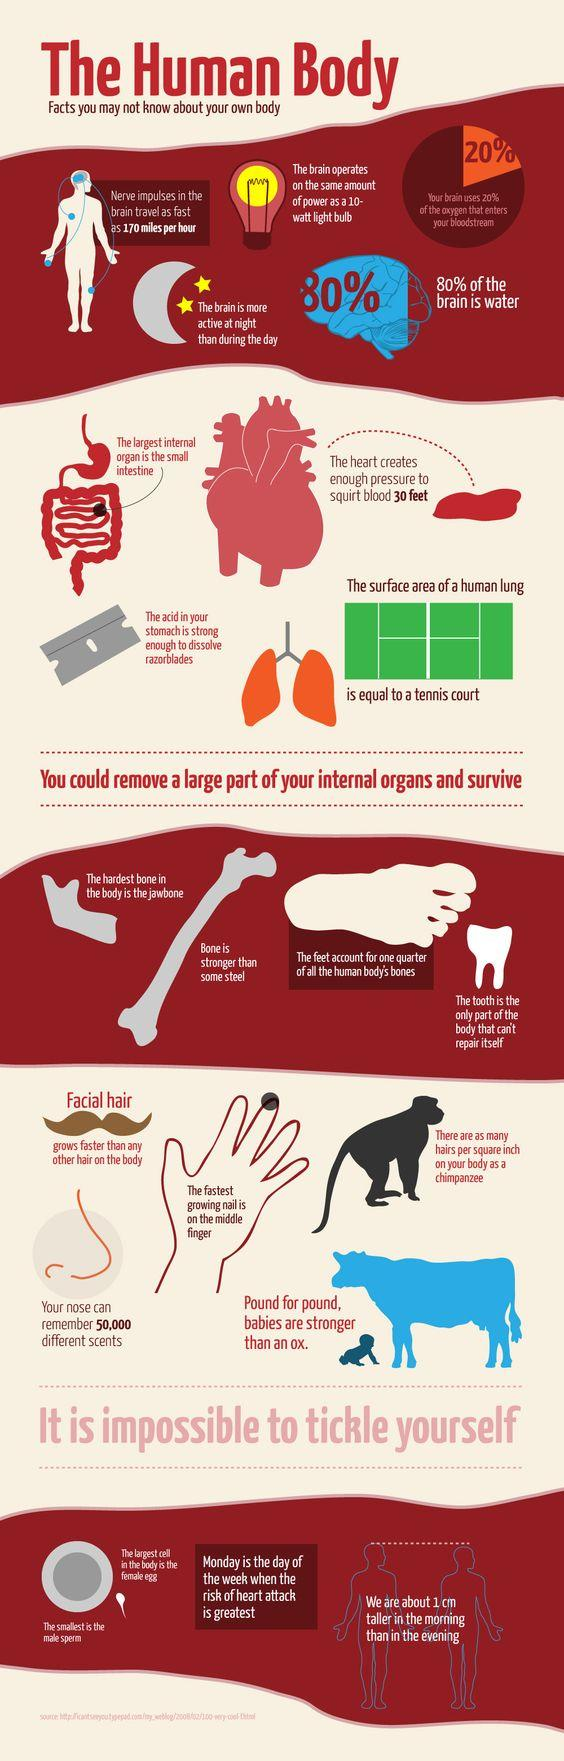Outline some significant characteristics in this image. The male sperm cell is the smallest cell in the human body. The time of day when our height is most significant is the morning. It is possible to dissolve a razor blade using acid from the human stomach. The power of the brain is equivalent to 10 watts. It is not possible for the human body to repair itself. Specifically, teeth are unable to repair themselves once they have been lost or extracted. 